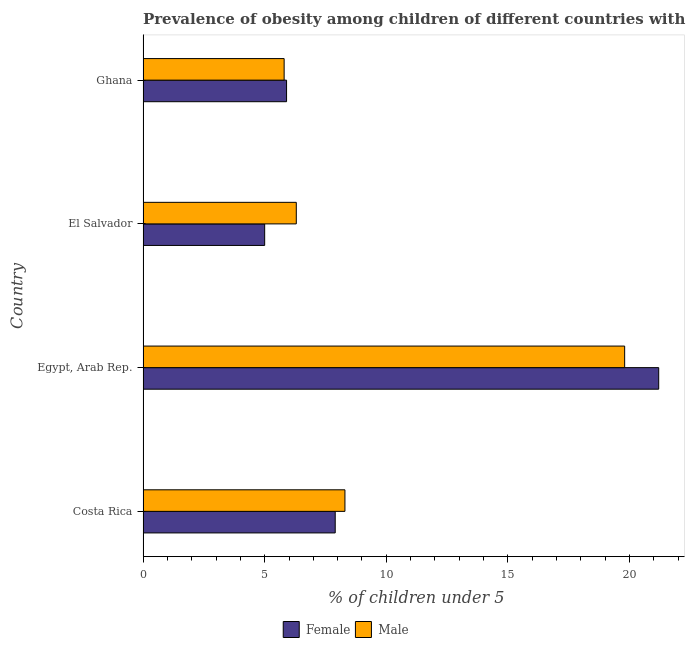How many different coloured bars are there?
Make the answer very short. 2. How many groups of bars are there?
Make the answer very short. 4. Are the number of bars on each tick of the Y-axis equal?
Your answer should be compact. Yes. How many bars are there on the 4th tick from the top?
Your response must be concise. 2. What is the label of the 3rd group of bars from the top?
Make the answer very short. Egypt, Arab Rep. In how many cases, is the number of bars for a given country not equal to the number of legend labels?
Offer a very short reply. 0. What is the percentage of obese male children in Ghana?
Your response must be concise. 5.8. Across all countries, what is the maximum percentage of obese female children?
Make the answer very short. 21.2. Across all countries, what is the minimum percentage of obese female children?
Your response must be concise. 5. In which country was the percentage of obese female children maximum?
Your answer should be very brief. Egypt, Arab Rep. In which country was the percentage of obese female children minimum?
Keep it short and to the point. El Salvador. What is the total percentage of obese male children in the graph?
Offer a very short reply. 40.2. What is the difference between the percentage of obese female children in Egypt, Arab Rep. and that in El Salvador?
Keep it short and to the point. 16.2. What is the difference between the percentage of obese male children in Costa Rica and the percentage of obese female children in Egypt, Arab Rep.?
Provide a short and direct response. -12.9. What is the average percentage of obese male children per country?
Keep it short and to the point. 10.05. What is the difference between the percentage of obese female children and percentage of obese male children in Costa Rica?
Offer a terse response. -0.4. What is the ratio of the percentage of obese male children in Egypt, Arab Rep. to that in El Salvador?
Offer a very short reply. 3.14. Are all the bars in the graph horizontal?
Provide a succinct answer. Yes. What is the difference between two consecutive major ticks on the X-axis?
Give a very brief answer. 5. Are the values on the major ticks of X-axis written in scientific E-notation?
Your answer should be very brief. No. Where does the legend appear in the graph?
Your response must be concise. Bottom center. How many legend labels are there?
Keep it short and to the point. 2. What is the title of the graph?
Provide a short and direct response. Prevalence of obesity among children of different countries with age under 5 years. What is the label or title of the X-axis?
Offer a terse response.  % of children under 5. What is the label or title of the Y-axis?
Offer a terse response. Country. What is the  % of children under 5 of Female in Costa Rica?
Offer a very short reply. 7.9. What is the  % of children under 5 in Male in Costa Rica?
Your answer should be compact. 8.3. What is the  % of children under 5 of Female in Egypt, Arab Rep.?
Offer a terse response. 21.2. What is the  % of children under 5 of Male in Egypt, Arab Rep.?
Offer a terse response. 19.8. What is the  % of children under 5 in Female in El Salvador?
Provide a short and direct response. 5. What is the  % of children under 5 of Male in El Salvador?
Keep it short and to the point. 6.3. What is the  % of children under 5 of Female in Ghana?
Your response must be concise. 5.9. What is the  % of children under 5 in Male in Ghana?
Provide a short and direct response. 5.8. Across all countries, what is the maximum  % of children under 5 in Female?
Offer a terse response. 21.2. Across all countries, what is the maximum  % of children under 5 in Male?
Offer a very short reply. 19.8. Across all countries, what is the minimum  % of children under 5 of Female?
Offer a terse response. 5. Across all countries, what is the minimum  % of children under 5 in Male?
Your response must be concise. 5.8. What is the total  % of children under 5 of Female in the graph?
Your answer should be compact. 40. What is the total  % of children under 5 in Male in the graph?
Your answer should be compact. 40.2. What is the difference between the  % of children under 5 of Male in Costa Rica and that in El Salvador?
Ensure brevity in your answer.  2. What is the difference between the  % of children under 5 in Female in Costa Rica and that in Ghana?
Make the answer very short. 2. What is the difference between the  % of children under 5 in Female in Egypt, Arab Rep. and that in Ghana?
Your response must be concise. 15.3. What is the difference between the  % of children under 5 in Female in El Salvador and that in Ghana?
Your response must be concise. -0.9. What is the difference between the  % of children under 5 in Female in Costa Rica and the  % of children under 5 in Male in Egypt, Arab Rep.?
Ensure brevity in your answer.  -11.9. What is the difference between the  % of children under 5 of Female in Costa Rica and the  % of children under 5 of Male in Ghana?
Give a very brief answer. 2.1. What is the difference between the  % of children under 5 of Female in Egypt, Arab Rep. and the  % of children under 5 of Male in El Salvador?
Keep it short and to the point. 14.9. What is the difference between the  % of children under 5 in Female in Egypt, Arab Rep. and the  % of children under 5 in Male in Ghana?
Offer a very short reply. 15.4. What is the average  % of children under 5 of Male per country?
Provide a succinct answer. 10.05. What is the difference between the  % of children under 5 in Female and  % of children under 5 in Male in Costa Rica?
Ensure brevity in your answer.  -0.4. What is the difference between the  % of children under 5 of Female and  % of children under 5 of Male in El Salvador?
Offer a terse response. -1.3. What is the difference between the  % of children under 5 in Female and  % of children under 5 in Male in Ghana?
Offer a very short reply. 0.1. What is the ratio of the  % of children under 5 of Female in Costa Rica to that in Egypt, Arab Rep.?
Offer a terse response. 0.37. What is the ratio of the  % of children under 5 in Male in Costa Rica to that in Egypt, Arab Rep.?
Your answer should be very brief. 0.42. What is the ratio of the  % of children under 5 of Female in Costa Rica to that in El Salvador?
Your response must be concise. 1.58. What is the ratio of the  % of children under 5 in Male in Costa Rica to that in El Salvador?
Give a very brief answer. 1.32. What is the ratio of the  % of children under 5 in Female in Costa Rica to that in Ghana?
Ensure brevity in your answer.  1.34. What is the ratio of the  % of children under 5 of Male in Costa Rica to that in Ghana?
Give a very brief answer. 1.43. What is the ratio of the  % of children under 5 in Female in Egypt, Arab Rep. to that in El Salvador?
Keep it short and to the point. 4.24. What is the ratio of the  % of children under 5 in Male in Egypt, Arab Rep. to that in El Salvador?
Offer a terse response. 3.14. What is the ratio of the  % of children under 5 of Female in Egypt, Arab Rep. to that in Ghana?
Offer a terse response. 3.59. What is the ratio of the  % of children under 5 in Male in Egypt, Arab Rep. to that in Ghana?
Your answer should be compact. 3.41. What is the ratio of the  % of children under 5 of Female in El Salvador to that in Ghana?
Provide a succinct answer. 0.85. What is the ratio of the  % of children under 5 of Male in El Salvador to that in Ghana?
Offer a very short reply. 1.09. What is the difference between the highest and the second highest  % of children under 5 in Male?
Provide a short and direct response. 11.5. What is the difference between the highest and the lowest  % of children under 5 in Male?
Make the answer very short. 14. 